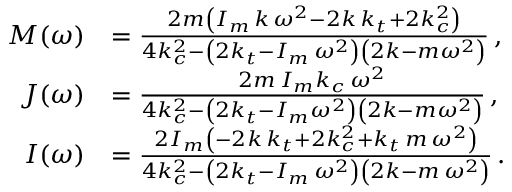<formula> <loc_0><loc_0><loc_500><loc_500>\begin{array} { r l } { M ( \omega ) } & { = \frac { 2 m \left ( I _ { m } \, k \, \omega ^ { 2 } - 2 k \, k _ { t } + 2 k _ { c } ^ { 2 } \right ) } { 4 k _ { c } ^ { 2 } - \left ( 2 k _ { t } - I _ { m } \, \omega ^ { 2 } \right ) \left ( 2 k - m \omega ^ { 2 } \right ) } \, , } \\ { J ( \omega ) } & { = \frac { 2 m \, I _ { m } k _ { c } \, \omega ^ { 2 } } { 4 k _ { c } ^ { 2 } - \left ( 2 k _ { t } - I _ { m } \omega ^ { 2 } \right ) \left ( 2 k - m \omega ^ { 2 } \right ) } \, , } \\ { I ( \omega ) } & { = \frac { 2 I _ { m } \left ( - 2 k \, k _ { t } + 2 k _ { c } ^ { 2 } + k _ { t } \, m \, \omega ^ { 2 } \right ) } { 4 k _ { c } ^ { 2 } - \left ( 2 k _ { t } - I _ { m } \, \omega ^ { 2 } \right ) \left ( 2 k - m \, \omega ^ { 2 } \right ) } \, . } \end{array}</formula> 